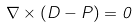Convert formula to latex. <formula><loc_0><loc_0><loc_500><loc_500>\nabla \times ( D - P ) = 0</formula> 